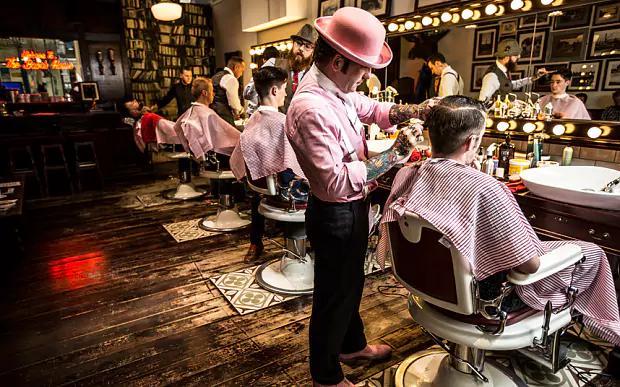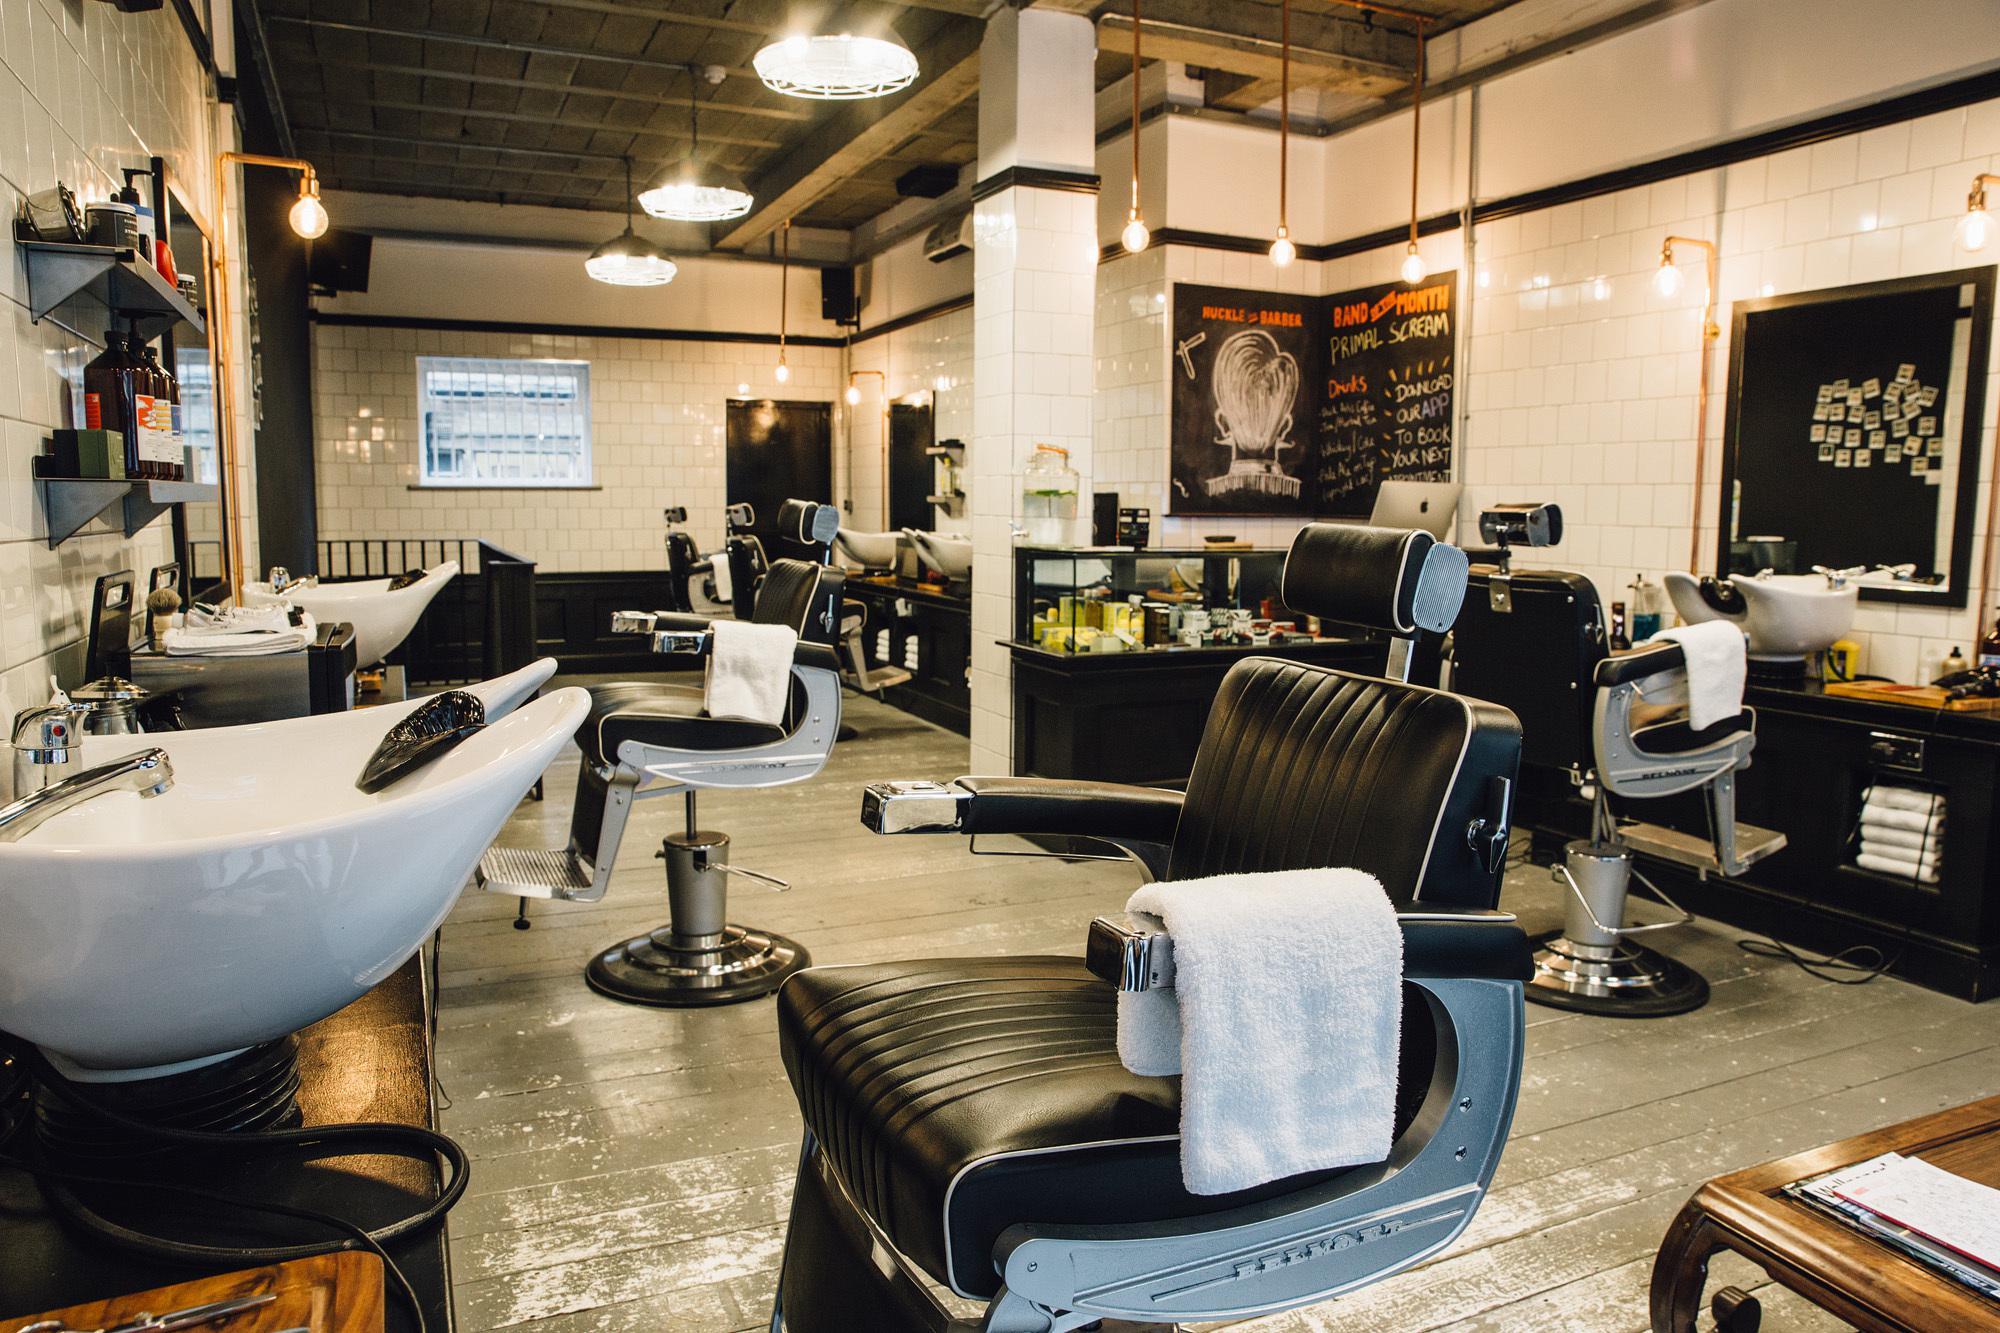The first image is the image on the left, the second image is the image on the right. Evaluate the accuracy of this statement regarding the images: "There is at least one person at a barber shop.". Is it true? Answer yes or no. Yes. 